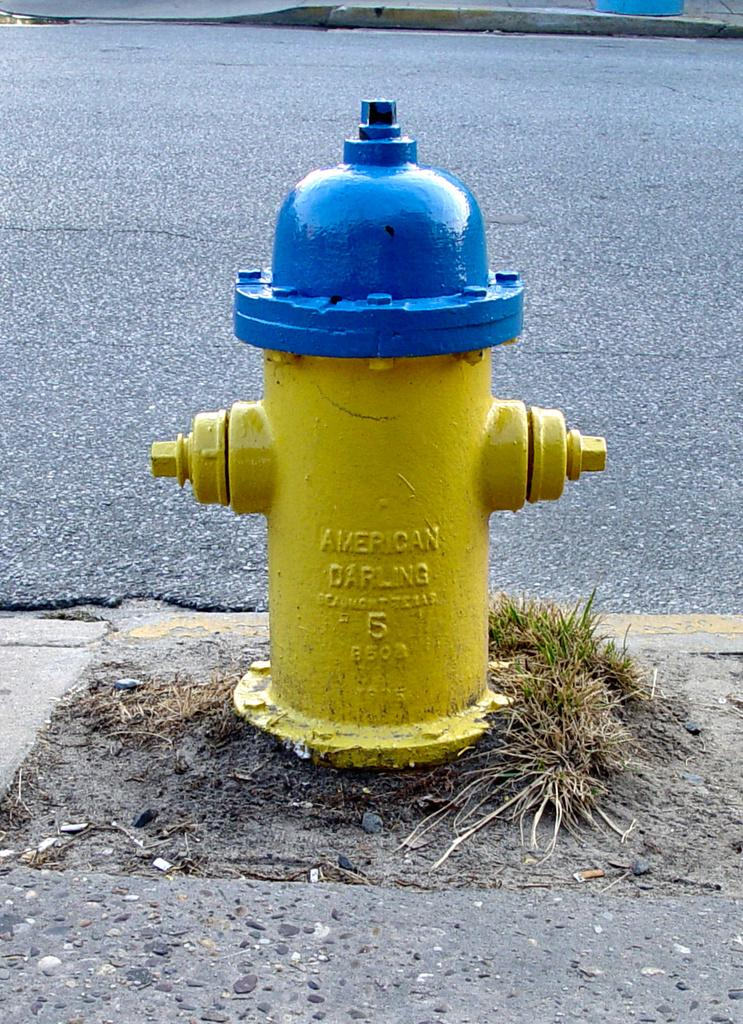What object is located on the footpath in the image? There is a fire hydrant on the footpath in the image. What colors are used to paint the fire hydrant? The fire hydrant is painted with blue and yellow colors. What can be seen in the background of the image? There is a road visible in the background of the image. What type of ship can be seen sailing in the background of the image? There is no ship present in the image; it only features a fire hydrant on the footpath and a road in the background. What emotion is the fire hydrant experiencing in the image? The fire hydrant is an inanimate object and does not experience emotions like fear. 